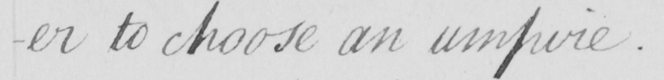Can you tell me what this handwritten text says? -er to choose an umpire . 